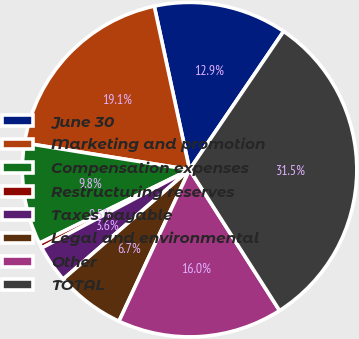<chart> <loc_0><loc_0><loc_500><loc_500><pie_chart><fcel>June 30<fcel>Marketing and promotion<fcel>Compensation expenses<fcel>Restructuring reserves<fcel>Taxes payable<fcel>Legal and environmental<fcel>Other<fcel>TOTAL<nl><fcel>12.89%<fcel>19.07%<fcel>9.79%<fcel>0.51%<fcel>3.61%<fcel>6.7%<fcel>15.98%<fcel>31.45%<nl></chart> 